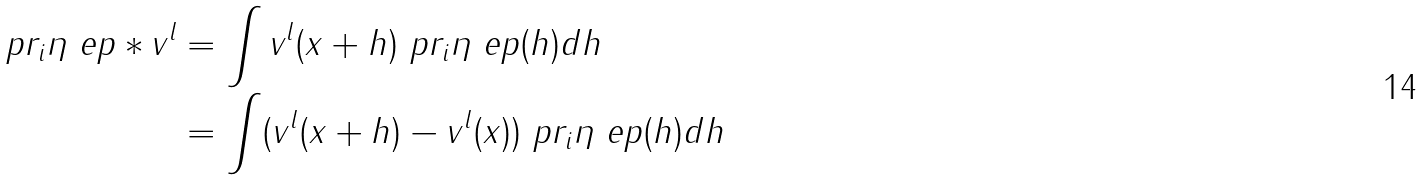<formula> <loc_0><loc_0><loc_500><loc_500>\ p r _ { i } \eta _ { \ } e p \ast v ^ { l } & = \int v ^ { l } ( x + h ) \ p r _ { i } \eta _ { \ } e p ( h ) d h \\ & = \int ( v ^ { l } ( x + h ) - v ^ { l } ( x ) ) \ p r _ { i } \eta _ { \ } e p ( h ) d h</formula> 